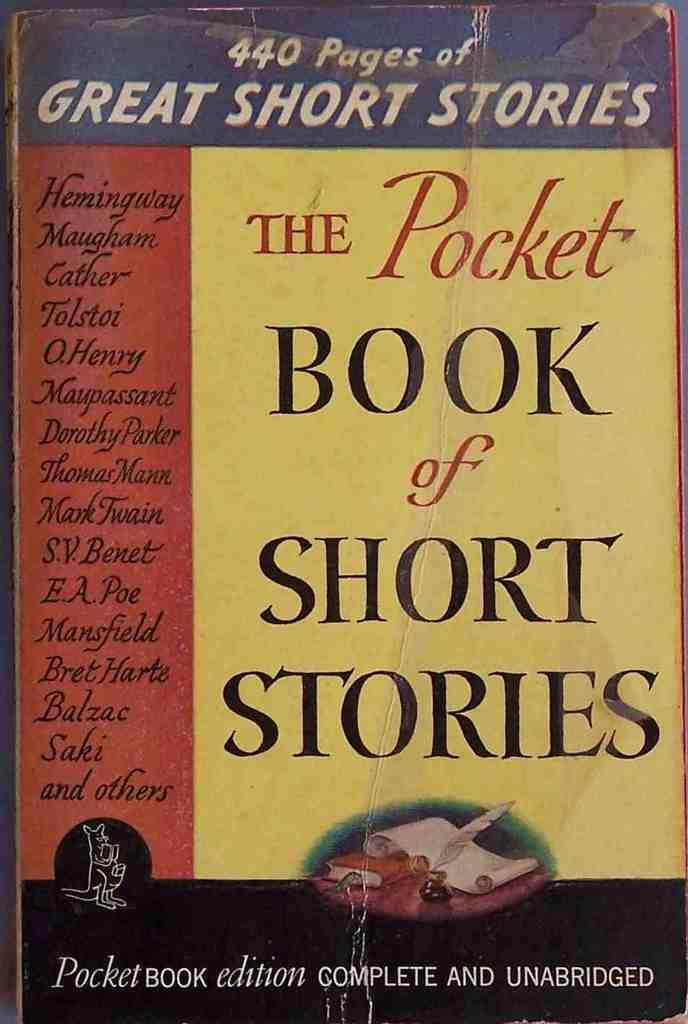Provide a one-sentence caption for the provided image. The cover of the Pocket Book of Short Stories can be seen. 